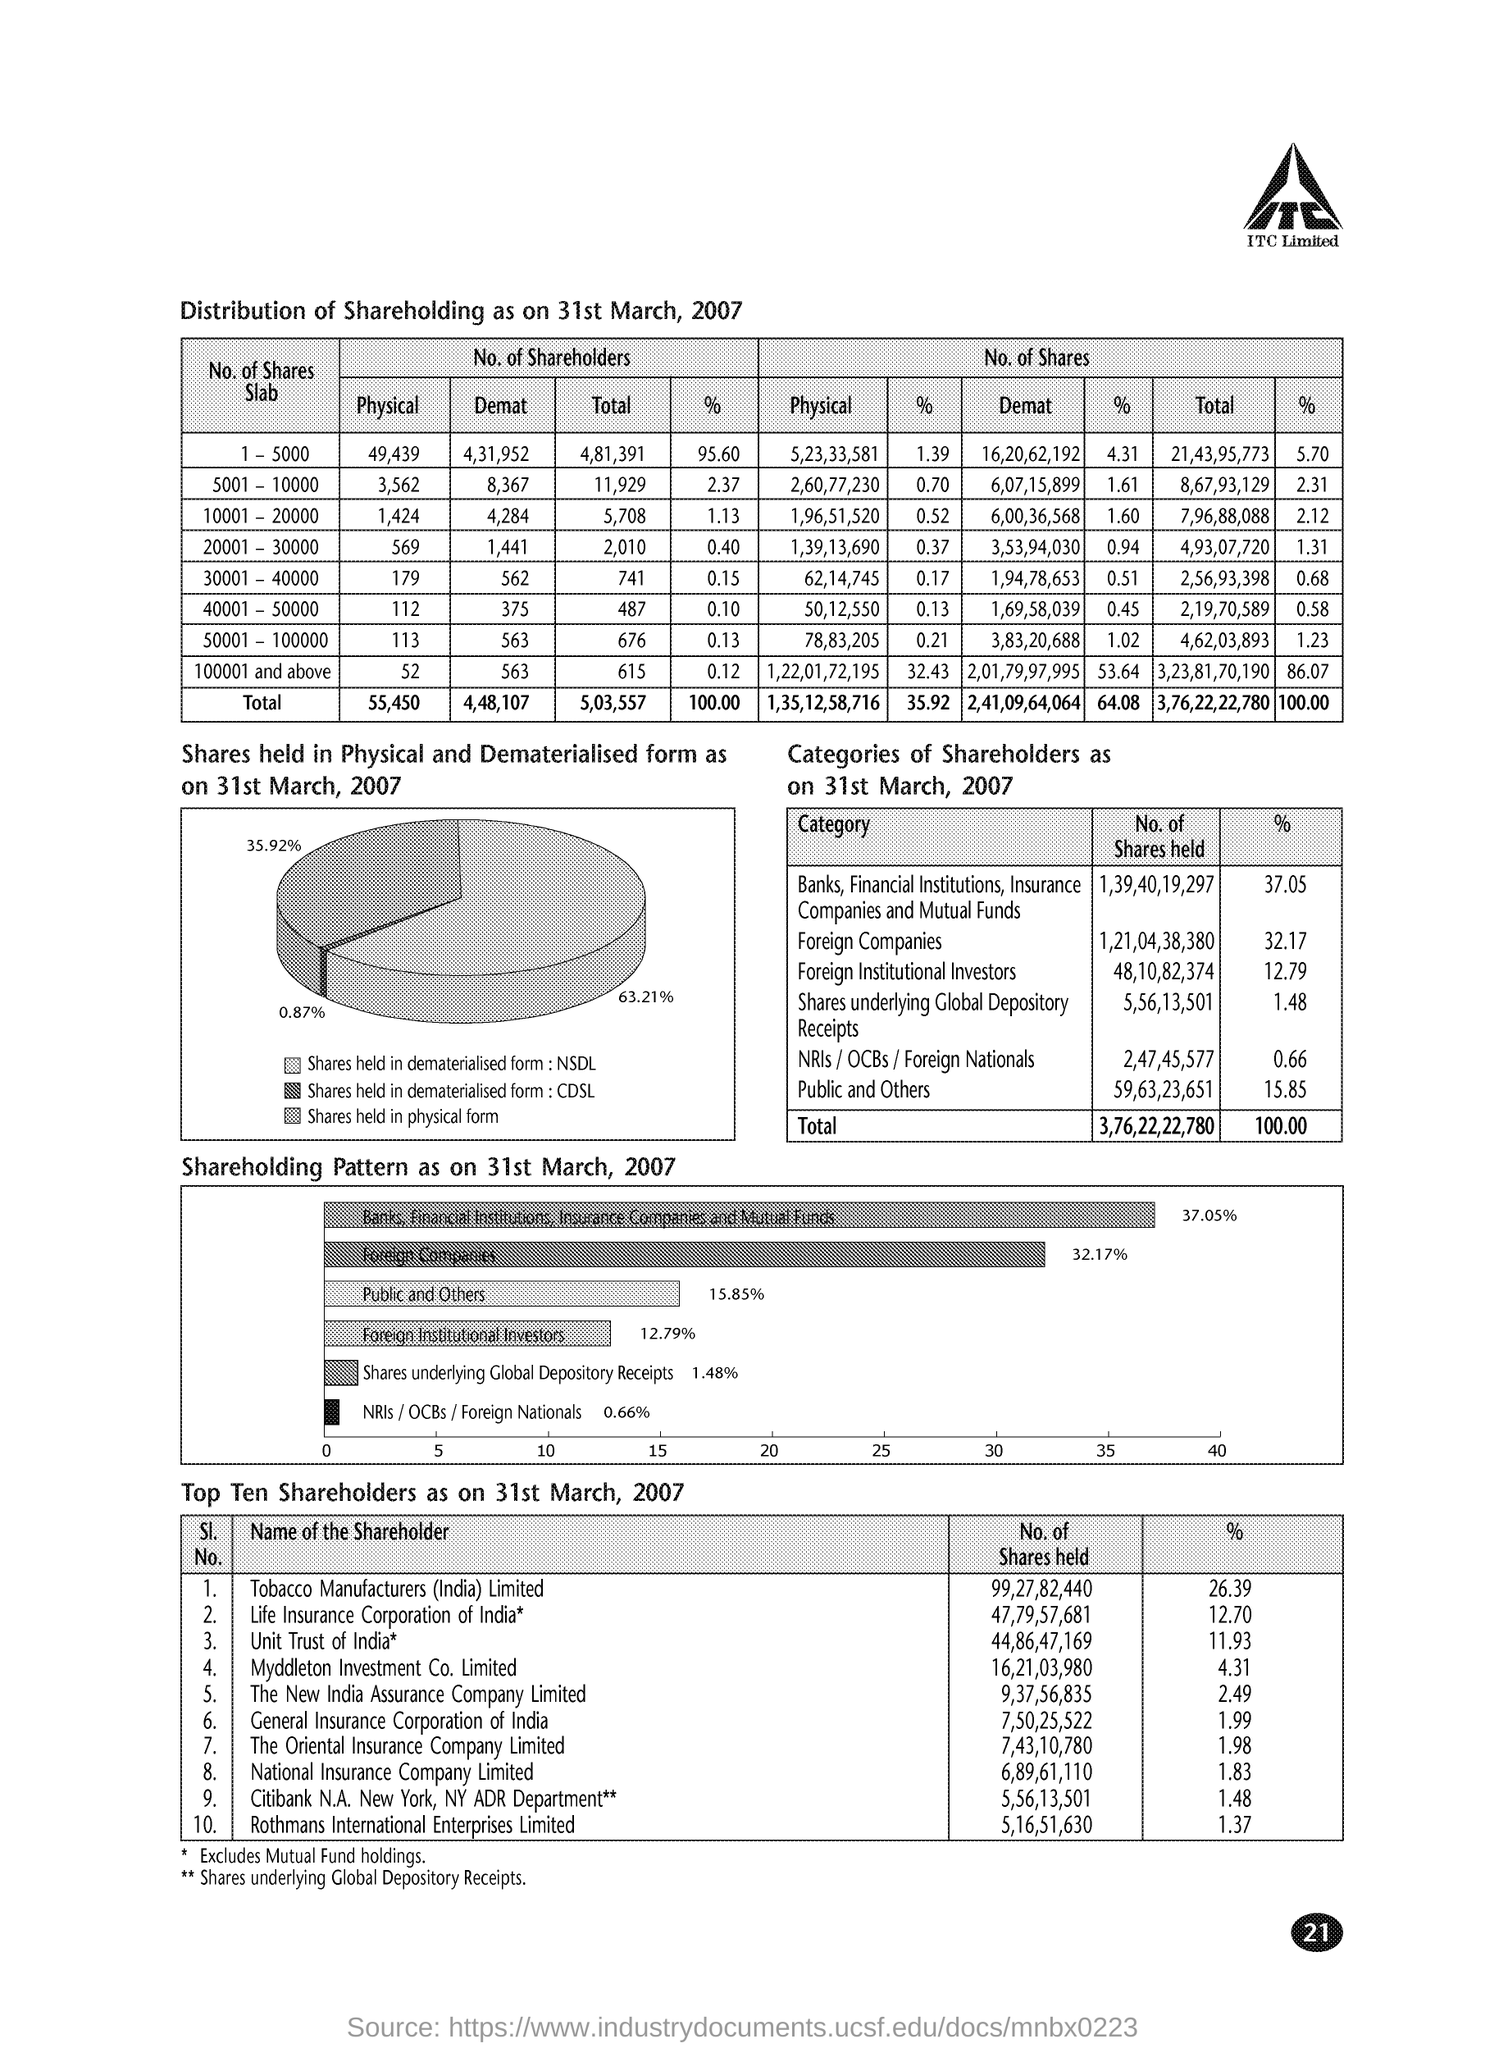What is the No. of Shares held by Tobacco Manufacturers (India) Limited as on 31st March, 2007?
Your response must be concise. 99,27,82,440. What is the No. of Shares held by National Insurance Company Limited as on 31st March, 2007?
Ensure brevity in your answer.  6,89,61,110. What percent of share is held by The Oriental Insurance Company Limited as on 31st March, 2007?
Your response must be concise. 1.98. What percent of share is held by The New India Assurance Company Limited as on 31st March, 2007?
Ensure brevity in your answer.  2.49. What is the No. of Shares held by Life Insurance Corporation of India as on 31st March, 2007?
Your answer should be compact. 47,79,57,681. What percent of share is held by Foreign Companies as on 31st March, 2007?
Your response must be concise. 32.17. What is the No. of Shares held by Foreign Institutional Investors as on 31st March, 2007?
Provide a short and direct response. 48,10,82,374. 